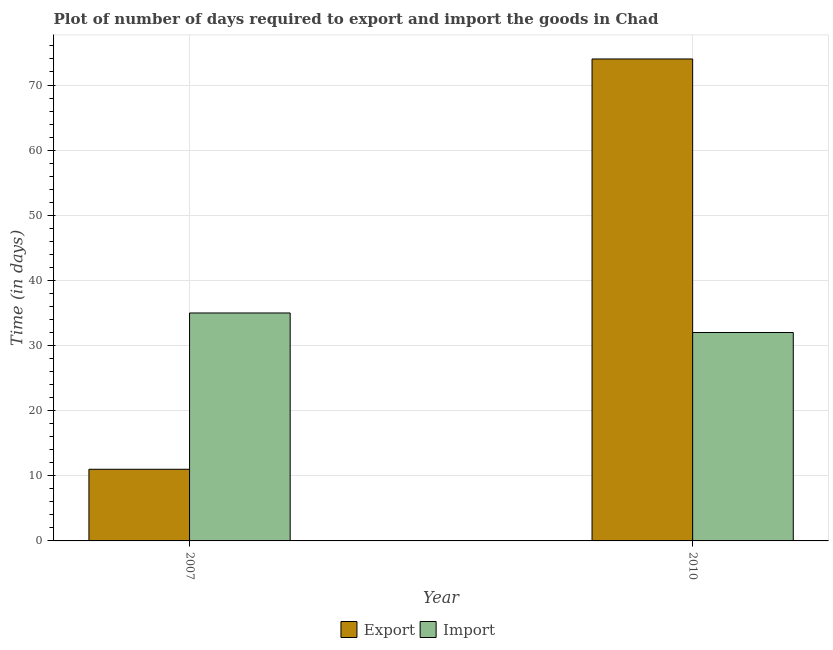How many groups of bars are there?
Give a very brief answer. 2. Are the number of bars on each tick of the X-axis equal?
Your response must be concise. Yes. How many bars are there on the 1st tick from the right?
Make the answer very short. 2. What is the label of the 2nd group of bars from the left?
Keep it short and to the point. 2010. What is the time required to export in 2010?
Your response must be concise. 74. Across all years, what is the maximum time required to import?
Your answer should be very brief. 35. Across all years, what is the minimum time required to export?
Keep it short and to the point. 11. What is the total time required to import in the graph?
Keep it short and to the point. 67. What is the difference between the time required to import in 2007 and that in 2010?
Make the answer very short. 3. What is the difference between the time required to export in 2010 and the time required to import in 2007?
Provide a short and direct response. 63. What is the average time required to import per year?
Provide a short and direct response. 33.5. In the year 2007, what is the difference between the time required to import and time required to export?
Offer a terse response. 0. What is the ratio of the time required to export in 2007 to that in 2010?
Give a very brief answer. 0.15. What does the 1st bar from the left in 2007 represents?
Ensure brevity in your answer.  Export. What does the 1st bar from the right in 2010 represents?
Keep it short and to the point. Import. How many years are there in the graph?
Give a very brief answer. 2. Are the values on the major ticks of Y-axis written in scientific E-notation?
Ensure brevity in your answer.  No. Does the graph contain grids?
Keep it short and to the point. Yes. How are the legend labels stacked?
Offer a terse response. Horizontal. What is the title of the graph?
Give a very brief answer. Plot of number of days required to export and import the goods in Chad. Does "Money lenders" appear as one of the legend labels in the graph?
Provide a succinct answer. No. What is the label or title of the X-axis?
Give a very brief answer. Year. What is the label or title of the Y-axis?
Your answer should be compact. Time (in days). What is the Time (in days) in Export in 2007?
Offer a terse response. 11. What is the Time (in days) of Import in 2007?
Your answer should be compact. 35. Across all years, what is the maximum Time (in days) in Export?
Provide a short and direct response. 74. Across all years, what is the maximum Time (in days) of Import?
Your response must be concise. 35. Across all years, what is the minimum Time (in days) in Export?
Provide a short and direct response. 11. Across all years, what is the minimum Time (in days) of Import?
Your answer should be very brief. 32. What is the difference between the Time (in days) in Export in 2007 and that in 2010?
Offer a terse response. -63. What is the difference between the Time (in days) of Export in 2007 and the Time (in days) of Import in 2010?
Offer a terse response. -21. What is the average Time (in days) of Export per year?
Provide a succinct answer. 42.5. What is the average Time (in days) in Import per year?
Your response must be concise. 33.5. What is the ratio of the Time (in days) in Export in 2007 to that in 2010?
Offer a very short reply. 0.15. What is the ratio of the Time (in days) of Import in 2007 to that in 2010?
Provide a succinct answer. 1.09. 